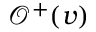<formula> <loc_0><loc_0><loc_500><loc_500>\mathcal { O } ^ { + } ( v )</formula> 